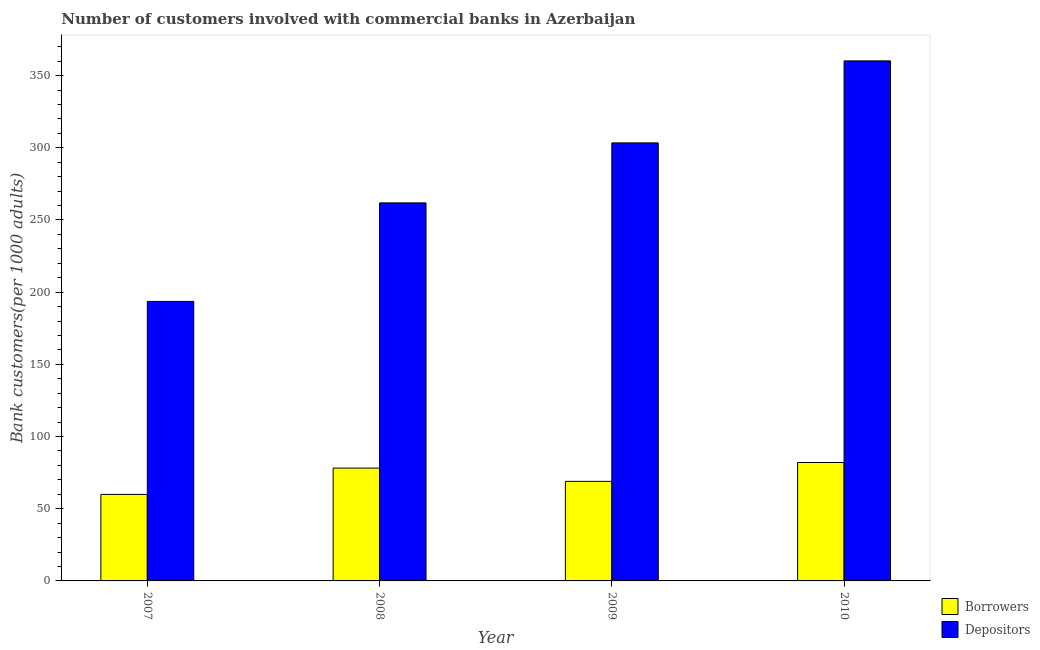How many different coloured bars are there?
Offer a terse response. 2. How many groups of bars are there?
Your answer should be compact. 4. Are the number of bars on each tick of the X-axis equal?
Offer a very short reply. Yes. How many bars are there on the 1st tick from the left?
Offer a very short reply. 2. How many bars are there on the 2nd tick from the right?
Provide a short and direct response. 2. What is the number of depositors in 2009?
Your answer should be very brief. 303.38. Across all years, what is the maximum number of depositors?
Provide a short and direct response. 360.2. Across all years, what is the minimum number of borrowers?
Provide a short and direct response. 59.93. What is the total number of borrowers in the graph?
Ensure brevity in your answer.  289.06. What is the difference between the number of depositors in 2009 and that in 2010?
Offer a very short reply. -56.81. What is the difference between the number of depositors in 2008 and the number of borrowers in 2007?
Provide a succinct answer. 68.24. What is the average number of borrowers per year?
Provide a succinct answer. 72.26. What is the ratio of the number of depositors in 2008 to that in 2010?
Keep it short and to the point. 0.73. What is the difference between the highest and the second highest number of borrowers?
Your answer should be very brief. 3.87. What is the difference between the highest and the lowest number of borrowers?
Provide a short and direct response. 22.09. In how many years, is the number of depositors greater than the average number of depositors taken over all years?
Provide a short and direct response. 2. What does the 2nd bar from the left in 2007 represents?
Give a very brief answer. Depositors. What does the 1st bar from the right in 2010 represents?
Keep it short and to the point. Depositors. Are the values on the major ticks of Y-axis written in scientific E-notation?
Make the answer very short. No. Does the graph contain any zero values?
Offer a terse response. No. Does the graph contain grids?
Ensure brevity in your answer.  No. What is the title of the graph?
Ensure brevity in your answer.  Number of customers involved with commercial banks in Azerbaijan. What is the label or title of the Y-axis?
Your answer should be compact. Bank customers(per 1000 adults). What is the Bank customers(per 1000 adults) of Borrowers in 2007?
Your response must be concise. 59.93. What is the Bank customers(per 1000 adults) of Depositors in 2007?
Keep it short and to the point. 193.59. What is the Bank customers(per 1000 adults) in Borrowers in 2008?
Make the answer very short. 78.15. What is the Bank customers(per 1000 adults) of Depositors in 2008?
Give a very brief answer. 261.83. What is the Bank customers(per 1000 adults) of Borrowers in 2009?
Ensure brevity in your answer.  68.96. What is the Bank customers(per 1000 adults) of Depositors in 2009?
Provide a succinct answer. 303.38. What is the Bank customers(per 1000 adults) of Borrowers in 2010?
Offer a very short reply. 82.02. What is the Bank customers(per 1000 adults) of Depositors in 2010?
Offer a terse response. 360.2. Across all years, what is the maximum Bank customers(per 1000 adults) of Borrowers?
Your response must be concise. 82.02. Across all years, what is the maximum Bank customers(per 1000 adults) in Depositors?
Ensure brevity in your answer.  360.2. Across all years, what is the minimum Bank customers(per 1000 adults) in Borrowers?
Your answer should be compact. 59.93. Across all years, what is the minimum Bank customers(per 1000 adults) of Depositors?
Ensure brevity in your answer.  193.59. What is the total Bank customers(per 1000 adults) in Borrowers in the graph?
Provide a short and direct response. 289.06. What is the total Bank customers(per 1000 adults) of Depositors in the graph?
Give a very brief answer. 1119. What is the difference between the Bank customers(per 1000 adults) in Borrowers in 2007 and that in 2008?
Make the answer very short. -18.22. What is the difference between the Bank customers(per 1000 adults) of Depositors in 2007 and that in 2008?
Make the answer very short. -68.24. What is the difference between the Bank customers(per 1000 adults) of Borrowers in 2007 and that in 2009?
Give a very brief answer. -9.03. What is the difference between the Bank customers(per 1000 adults) in Depositors in 2007 and that in 2009?
Your response must be concise. -109.8. What is the difference between the Bank customers(per 1000 adults) of Borrowers in 2007 and that in 2010?
Offer a terse response. -22.09. What is the difference between the Bank customers(per 1000 adults) of Depositors in 2007 and that in 2010?
Make the answer very short. -166.61. What is the difference between the Bank customers(per 1000 adults) in Borrowers in 2008 and that in 2009?
Offer a very short reply. 9.19. What is the difference between the Bank customers(per 1000 adults) of Depositors in 2008 and that in 2009?
Offer a terse response. -41.55. What is the difference between the Bank customers(per 1000 adults) of Borrowers in 2008 and that in 2010?
Offer a very short reply. -3.87. What is the difference between the Bank customers(per 1000 adults) in Depositors in 2008 and that in 2010?
Give a very brief answer. -98.36. What is the difference between the Bank customers(per 1000 adults) in Borrowers in 2009 and that in 2010?
Your response must be concise. -13.07. What is the difference between the Bank customers(per 1000 adults) in Depositors in 2009 and that in 2010?
Make the answer very short. -56.81. What is the difference between the Bank customers(per 1000 adults) of Borrowers in 2007 and the Bank customers(per 1000 adults) of Depositors in 2008?
Provide a succinct answer. -201.9. What is the difference between the Bank customers(per 1000 adults) of Borrowers in 2007 and the Bank customers(per 1000 adults) of Depositors in 2009?
Your answer should be very brief. -243.45. What is the difference between the Bank customers(per 1000 adults) in Borrowers in 2007 and the Bank customers(per 1000 adults) in Depositors in 2010?
Offer a terse response. -300.27. What is the difference between the Bank customers(per 1000 adults) of Borrowers in 2008 and the Bank customers(per 1000 adults) of Depositors in 2009?
Your answer should be very brief. -225.23. What is the difference between the Bank customers(per 1000 adults) in Borrowers in 2008 and the Bank customers(per 1000 adults) in Depositors in 2010?
Ensure brevity in your answer.  -282.05. What is the difference between the Bank customers(per 1000 adults) in Borrowers in 2009 and the Bank customers(per 1000 adults) in Depositors in 2010?
Your answer should be very brief. -291.24. What is the average Bank customers(per 1000 adults) of Borrowers per year?
Offer a terse response. 72.26. What is the average Bank customers(per 1000 adults) of Depositors per year?
Your answer should be very brief. 279.75. In the year 2007, what is the difference between the Bank customers(per 1000 adults) of Borrowers and Bank customers(per 1000 adults) of Depositors?
Provide a short and direct response. -133.66. In the year 2008, what is the difference between the Bank customers(per 1000 adults) of Borrowers and Bank customers(per 1000 adults) of Depositors?
Offer a terse response. -183.68. In the year 2009, what is the difference between the Bank customers(per 1000 adults) of Borrowers and Bank customers(per 1000 adults) of Depositors?
Your answer should be compact. -234.43. In the year 2010, what is the difference between the Bank customers(per 1000 adults) in Borrowers and Bank customers(per 1000 adults) in Depositors?
Provide a short and direct response. -278.17. What is the ratio of the Bank customers(per 1000 adults) in Borrowers in 2007 to that in 2008?
Offer a terse response. 0.77. What is the ratio of the Bank customers(per 1000 adults) in Depositors in 2007 to that in 2008?
Your response must be concise. 0.74. What is the ratio of the Bank customers(per 1000 adults) in Borrowers in 2007 to that in 2009?
Offer a terse response. 0.87. What is the ratio of the Bank customers(per 1000 adults) of Depositors in 2007 to that in 2009?
Your response must be concise. 0.64. What is the ratio of the Bank customers(per 1000 adults) in Borrowers in 2007 to that in 2010?
Ensure brevity in your answer.  0.73. What is the ratio of the Bank customers(per 1000 adults) in Depositors in 2007 to that in 2010?
Keep it short and to the point. 0.54. What is the ratio of the Bank customers(per 1000 adults) in Borrowers in 2008 to that in 2009?
Give a very brief answer. 1.13. What is the ratio of the Bank customers(per 1000 adults) in Depositors in 2008 to that in 2009?
Give a very brief answer. 0.86. What is the ratio of the Bank customers(per 1000 adults) in Borrowers in 2008 to that in 2010?
Offer a very short reply. 0.95. What is the ratio of the Bank customers(per 1000 adults) in Depositors in 2008 to that in 2010?
Provide a succinct answer. 0.73. What is the ratio of the Bank customers(per 1000 adults) in Borrowers in 2009 to that in 2010?
Make the answer very short. 0.84. What is the ratio of the Bank customers(per 1000 adults) in Depositors in 2009 to that in 2010?
Provide a short and direct response. 0.84. What is the difference between the highest and the second highest Bank customers(per 1000 adults) of Borrowers?
Your response must be concise. 3.87. What is the difference between the highest and the second highest Bank customers(per 1000 adults) in Depositors?
Give a very brief answer. 56.81. What is the difference between the highest and the lowest Bank customers(per 1000 adults) in Borrowers?
Offer a terse response. 22.09. What is the difference between the highest and the lowest Bank customers(per 1000 adults) of Depositors?
Provide a succinct answer. 166.61. 